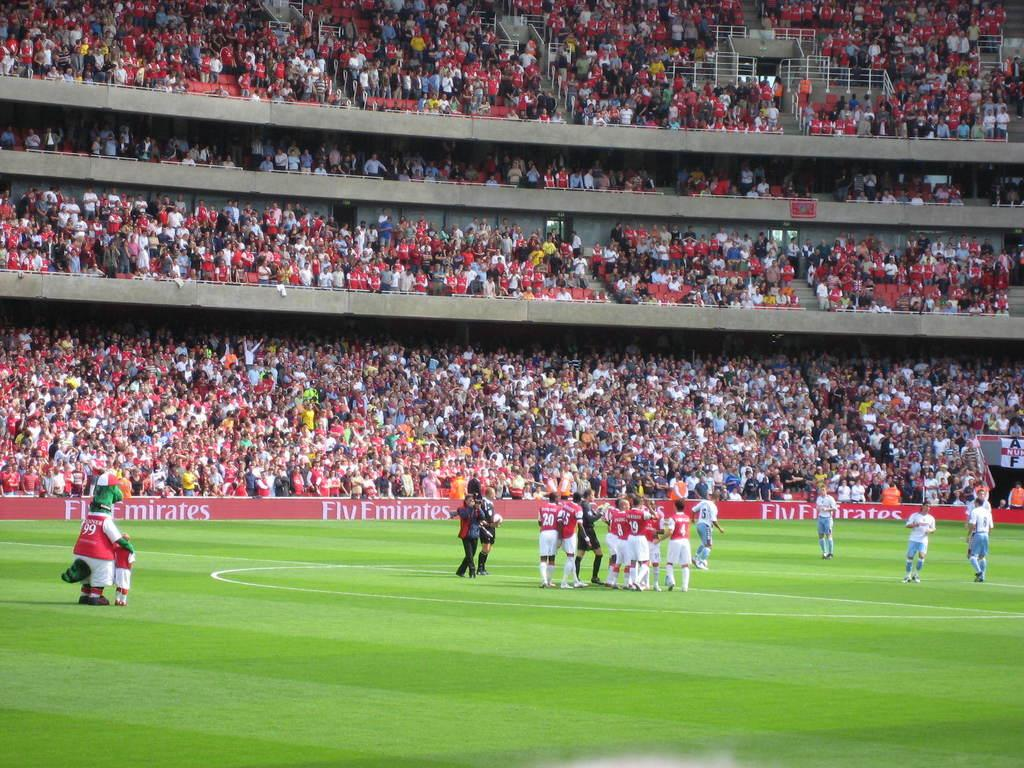<image>
Create a compact narrative representing the image presented. A mascot wearing 99 stands by a young fan on a soccer field. 